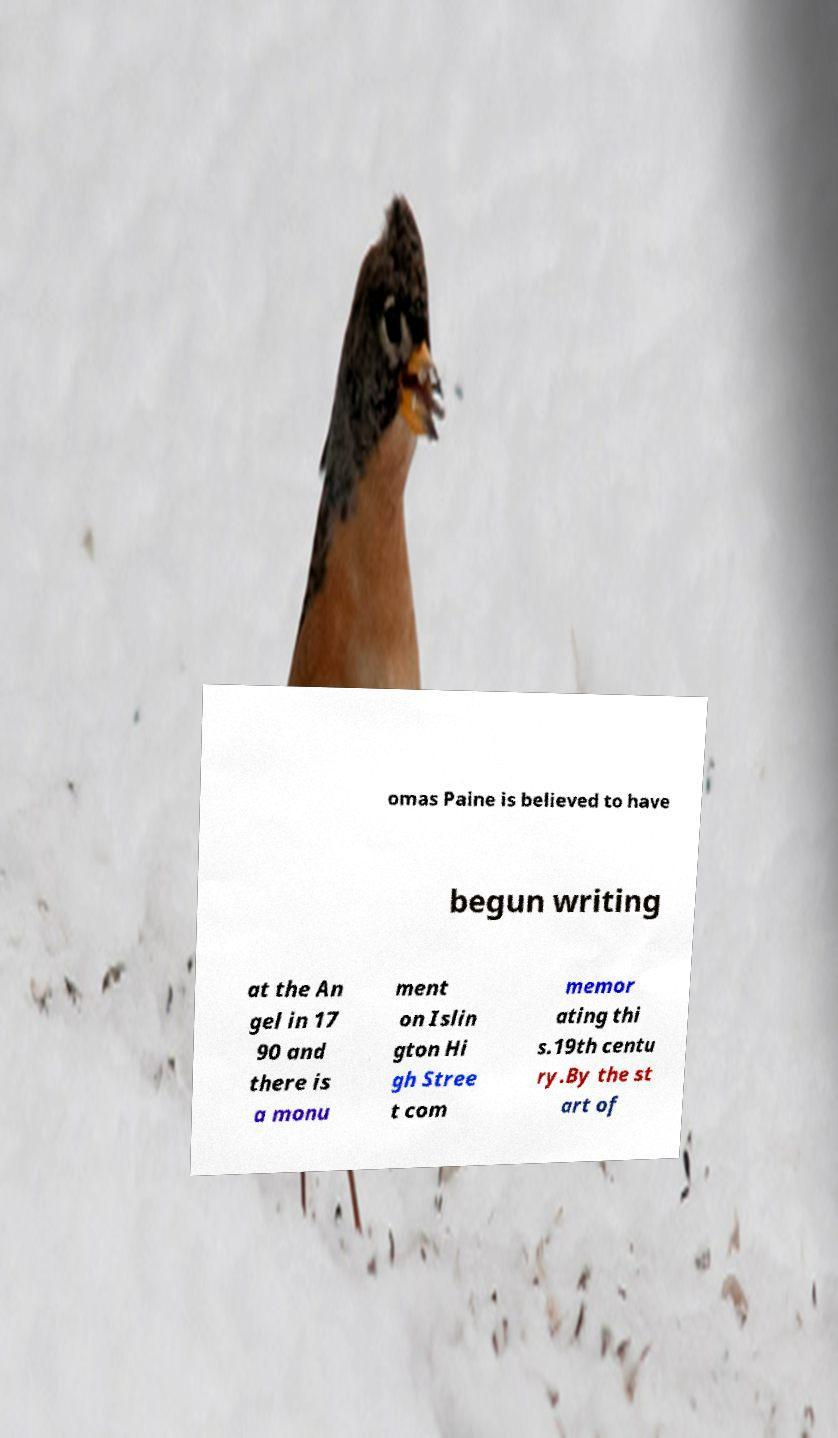Please identify and transcribe the text found in this image. omas Paine is believed to have begun writing at the An gel in 17 90 and there is a monu ment on Islin gton Hi gh Stree t com memor ating thi s.19th centu ry.By the st art of 